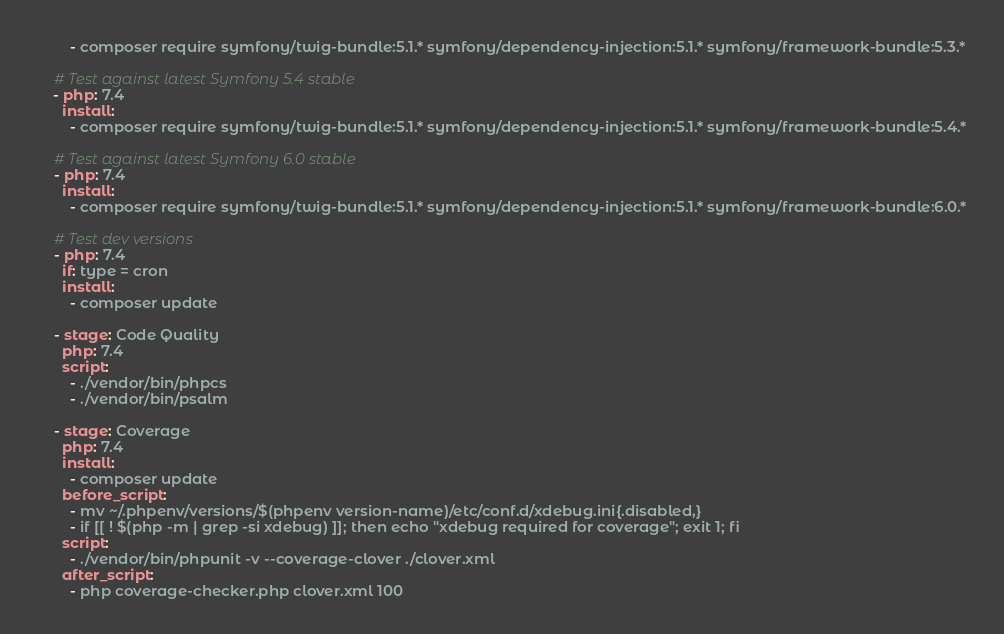<code> <loc_0><loc_0><loc_500><loc_500><_YAML_>        - composer require symfony/twig-bundle:5.1.* symfony/dependency-injection:5.1.* symfony/framework-bundle:5.3.*

    # Test against latest Symfony 5.4 stable
    - php: 7.4
      install:
        - composer require symfony/twig-bundle:5.1.* symfony/dependency-injection:5.1.* symfony/framework-bundle:5.4.*

    # Test against latest Symfony 6.0 stable
    - php: 7.4
      install:
        - composer require symfony/twig-bundle:5.1.* symfony/dependency-injection:5.1.* symfony/framework-bundle:6.0.*

    # Test dev versions
    - php: 7.4
      if: type = cron
      install:
        - composer update

    - stage: Code Quality
      php: 7.4
      script:
        - ./vendor/bin/phpcs
        - ./vendor/bin/psalm

    - stage: Coverage
      php: 7.4
      install:
        - composer update
      before_script:
        - mv ~/.phpenv/versions/$(phpenv version-name)/etc/conf.d/xdebug.ini{.disabled,}
        - if [[ ! $(php -m | grep -si xdebug) ]]; then echo "xdebug required for coverage"; exit 1; fi
      script:
        - ./vendor/bin/phpunit -v --coverage-clover ./clover.xml
      after_script:
        - php coverage-checker.php clover.xml 100
</code> 